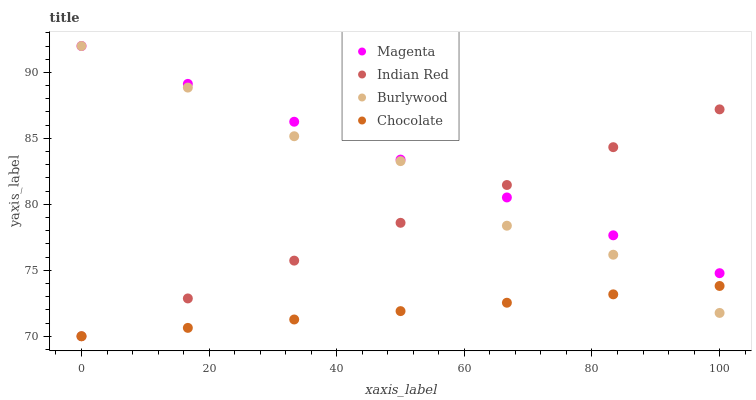Does Chocolate have the minimum area under the curve?
Answer yes or no. Yes. Does Magenta have the maximum area under the curve?
Answer yes or no. Yes. Does Indian Red have the minimum area under the curve?
Answer yes or no. No. Does Indian Red have the maximum area under the curve?
Answer yes or no. No. Is Magenta the smoothest?
Answer yes or no. Yes. Is Burlywood the roughest?
Answer yes or no. Yes. Is Indian Red the smoothest?
Answer yes or no. No. Is Indian Red the roughest?
Answer yes or no. No. Does Indian Red have the lowest value?
Answer yes or no. Yes. Does Magenta have the lowest value?
Answer yes or no. No. Does Magenta have the highest value?
Answer yes or no. Yes. Does Indian Red have the highest value?
Answer yes or no. No. Is Chocolate less than Magenta?
Answer yes or no. Yes. Is Magenta greater than Chocolate?
Answer yes or no. Yes. Does Chocolate intersect Burlywood?
Answer yes or no. Yes. Is Chocolate less than Burlywood?
Answer yes or no. No. Is Chocolate greater than Burlywood?
Answer yes or no. No. Does Chocolate intersect Magenta?
Answer yes or no. No. 